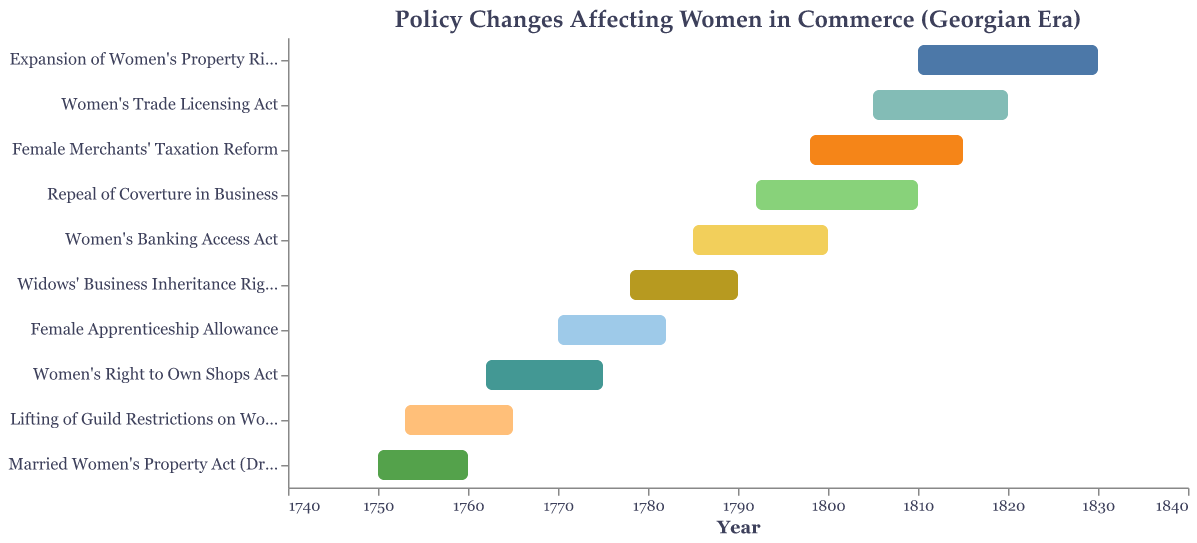What is the title of the figure? The title is provided directly at the top of the figure and states the main subject.
Answer: Policy Changes Affecting Women in Commerce (Georgian Era) How many policy changes are listed on the chart? By counting the number of rows, each representing a different policy change, we determine the total.
Answer: 10 Which policy lasted the shortest period? By comparing the start and end years of each policy, the policy with the smallest time span can be identified. The 'Married Women's Property Act (Draft)' lasted from 1750 to 1760, which is the shortest period.
Answer: Married Women's Property Act (Draft) During which years did both the 'Women's Banking Access Act' and 'Repeal of Coverture in Business' policies overlap? Identify the overlapping period by noting the years both policies were in effect. The 'Women's Banking Access Act' was from 1785-1800, and 'Repeal of Coverture in Business' was from 1792-1810. The overlapping period is 1792-1800.
Answer: 1792-1800 Which policy started immediately after the 'Lifting of Guild Restrictions on Women'? Identify the end year of 'Lifting of Guild Restrictions on Women' and check which policy begins immediately after. It ended in 1765, and 'Women's Right to Own Shops Act' started in 1762, before 1765, so look for the next policy after 1765, which is 'Female Apprenticeship Allowance.'
Answer: Female Apprenticeship Allowance What is the average duration of all the policy changes? Calculate the duration of each policy by subtracting the start year from the end year, sum these durations, and divide by the number of policies. Durations: 10, 12, 13, 12, 12, 15, 18, 17, 15, 20. Sum = 144. Average=144/10=14.4 years.
Answer: 14.4 years Which policy had the longest duration? Compare the durations of all policies by subtracting their start year from their end year. 'Expansion of Women's Property Rights' from 1810-1830 lasts 20 years, which is the longest duration.
Answer: Expansion of Women's Property Rights How many policies were enacted before 1800? Count the policies that have a start date earlier than 1800. They are: 'Married Women's Property Act (Draft)', 'Lifting of Guild Restrictions on Women', 'Women's Right to Own Shops Act', 'Female Apprenticeship Allowance', 'Widows' Business Inheritance Rights', 'Women's Banking Access Act', 'Repeal of Coverture in Business', and 'Female Merchants' Taxation Reform' (8 policies).
Answer: 8 Which policies were active during the year 1782? Identify the policies that encompass the year 1782 between their start and end years. Active policies are 'Female Apprenticeship Allowance' (1770-1782) and 'Widows' Business Inheritance Rights' (1778-1790).
Answer: Female Apprenticeship Allowance, Widows' Business Inheritance Rights 